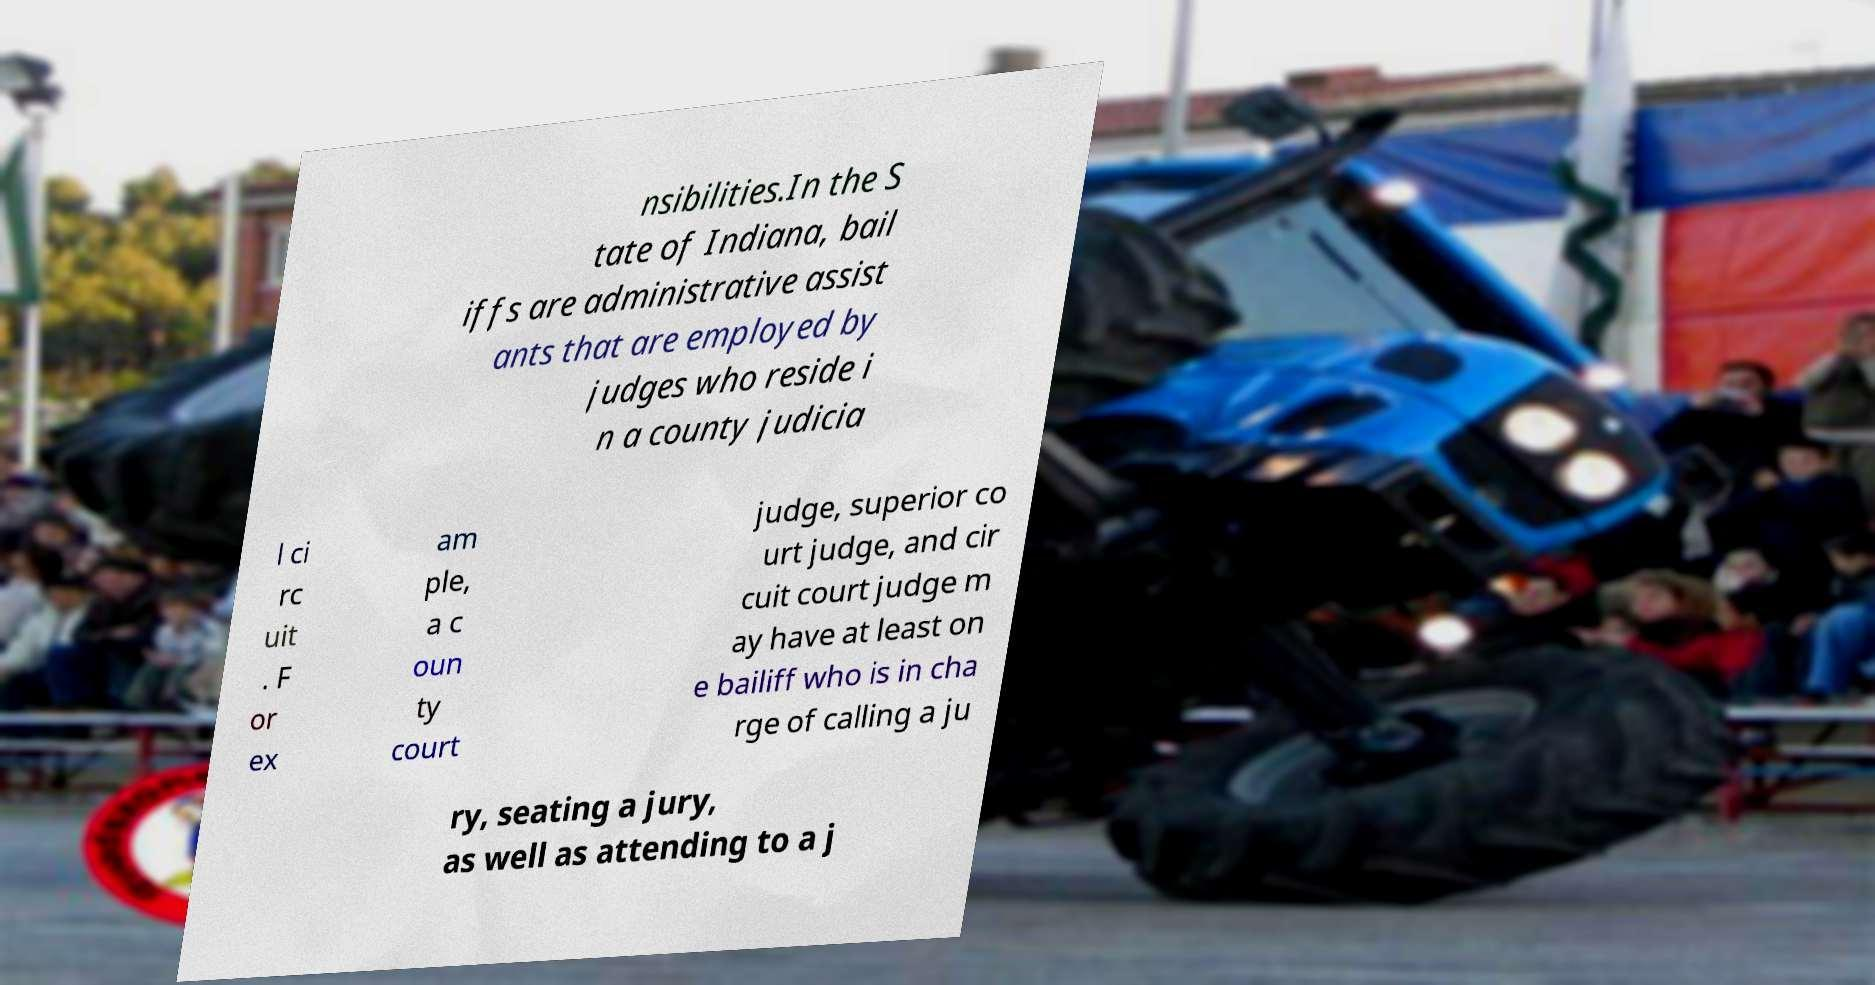I need the written content from this picture converted into text. Can you do that? nsibilities.In the S tate of Indiana, bail iffs are administrative assist ants that are employed by judges who reside i n a county judicia l ci rc uit . F or ex am ple, a c oun ty court judge, superior co urt judge, and cir cuit court judge m ay have at least on e bailiff who is in cha rge of calling a ju ry, seating a jury, as well as attending to a j 